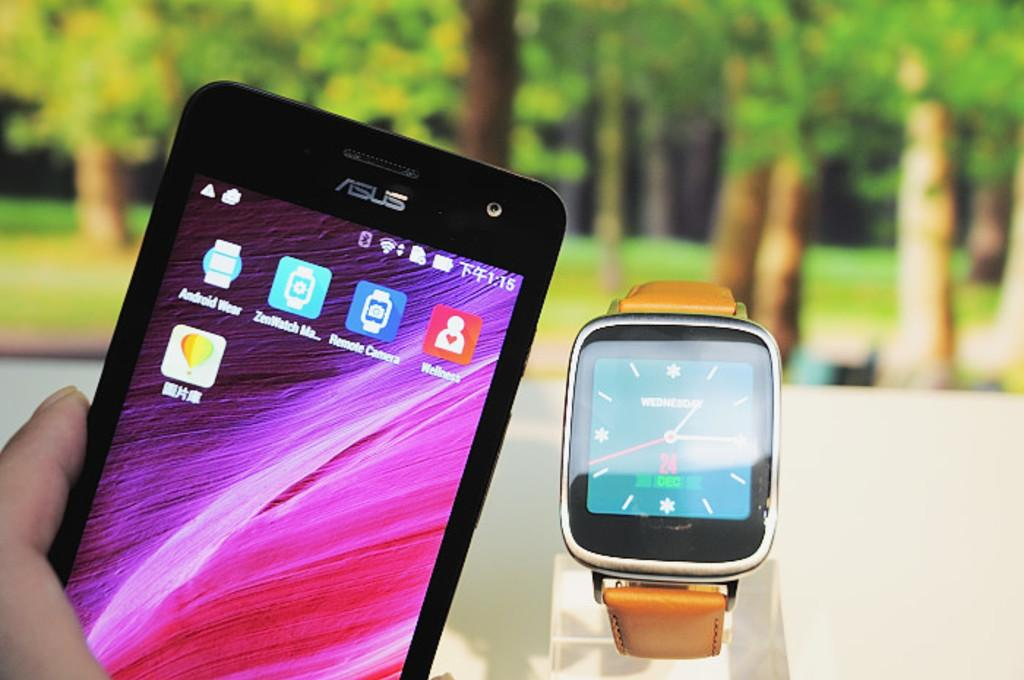<image>
Share a concise interpretation of the image provided. Smartphone Screen with a Watch that says Wednesday, Dec 24 on the interface. 